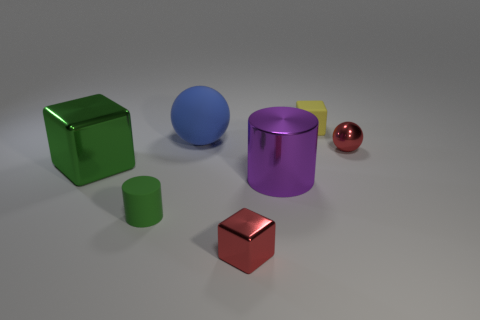Subtract all metal blocks. How many blocks are left? 1 Subtract 1 blocks. How many blocks are left? 2 Add 2 blue shiny things. How many objects exist? 9 Subtract all balls. How many objects are left? 5 Add 2 tiny matte objects. How many tiny matte objects are left? 4 Add 3 tiny metal cubes. How many tiny metal cubes exist? 4 Subtract 1 green cubes. How many objects are left? 6 Subtract all cyan cylinders. Subtract all yellow balls. How many cylinders are left? 2 Subtract all big metallic cylinders. Subtract all large blue matte objects. How many objects are left? 5 